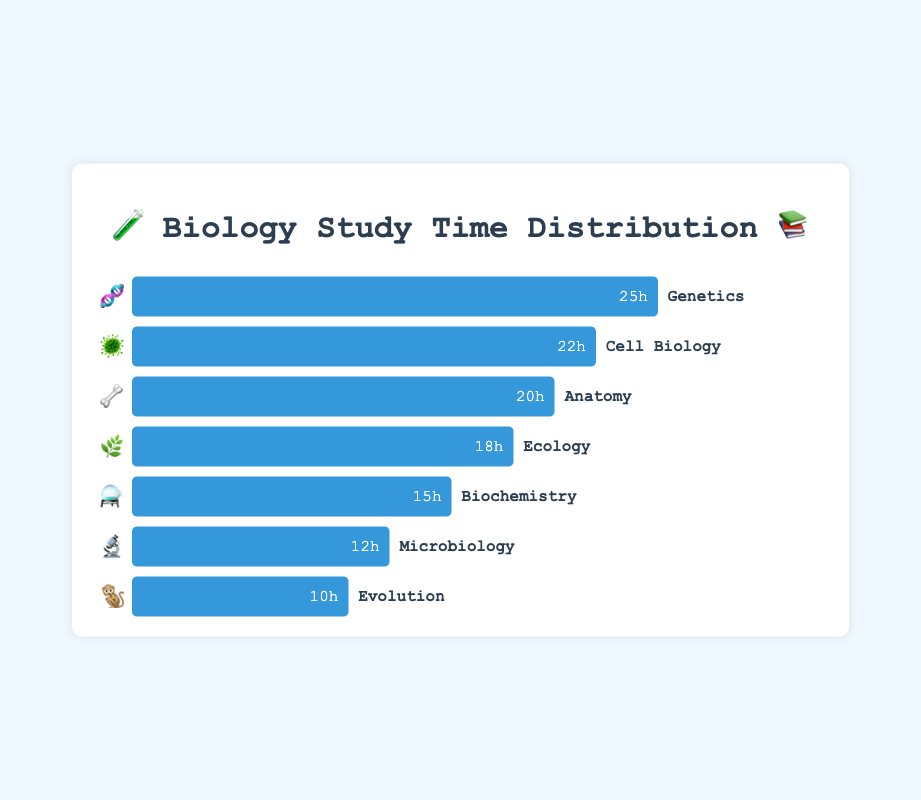Which subject has the highest study time? Genetics shows the highest study time with 25 hours based on the width of the bar and the number displayed within the bar.
Answer: Genetics What is the total study time for Anatomy and Biochemistry combined? The study time for Anatomy is 20 hours, and for Biochemistry, it is 15 hours. Adding these gives 20 + 15 = 35 hours.
Answer: 35 Which subject requires less study time than Ecology but more than Evolution? Based on the chart, Microbiology has 12 hours of study time which is less than Ecology's 18 hours but more than Evolution's 10 hours.
Answer: Microbiology How much more time do students spend studying Genetics compared to Evolution? Genetics involves 25 hours while Evolution involves 10 hours, which means students spend 25 - 10 = 15 more hours on Genetics.
Answer: 15 Rank the subjects from most to least study time. Observing the lengths of the bars and the numbers within them, the order from most to least study time is: Genetics, Cell Biology, Anatomy, Ecology, Biochemistry, Microbiology, Evolution.
Answer: Genetics, Cell Biology, Anatomy, Ecology, Biochemistry, Microbiology, Evolution What is the average study time across all subjects? Adding all study times: 25 (Genetics) + 18 (Ecology) + 22 (Cell Biology) + 20 (Anatomy) + 15 (Biochemistry) + 12 (Microbiology) + 10 (Evolution) = 122 hours. Dividing by the number of subjects, 122 / 7 ≈ 17.43 hours.
Answer: 17.43 Which subjects have a study time greater than 15 hours? The subjects with bars longer than 15 hours are Genetics (25), Cell Biology (22), Anatomy (20), and Ecology (18).
Answer: Genetics, Cell Biology, Anatomy, Ecology Which subject has the closest study time to the average study time? The average study time is approximately 17.43 hours. Ecology has 18 hours, which is closest to the average.
Answer: Ecology 